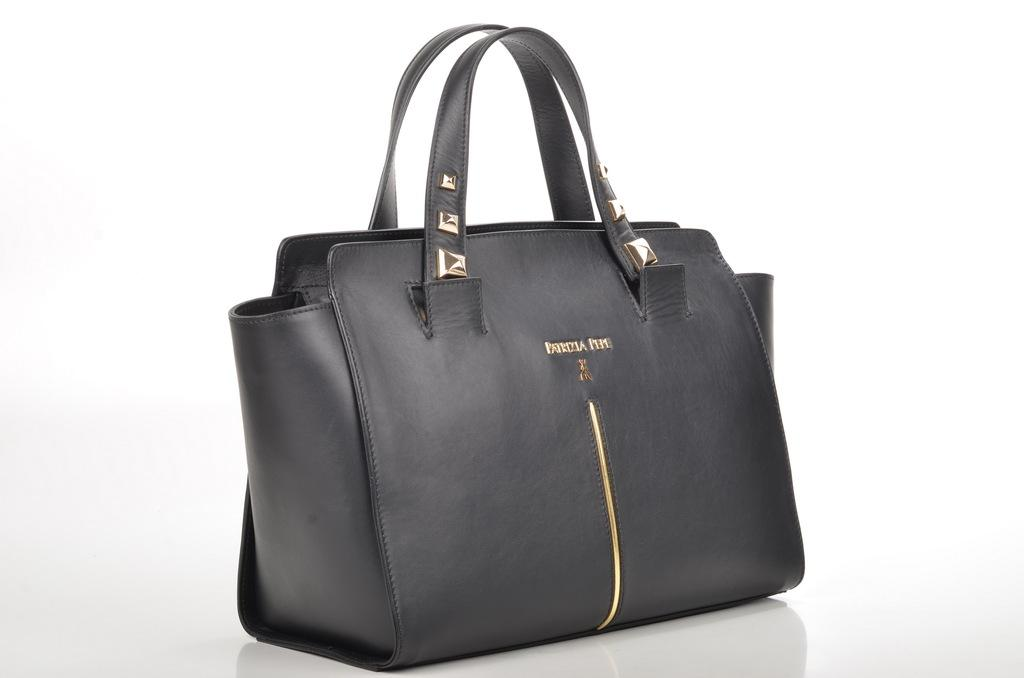What type of accessory is featured in the image? There is a black handbag in the image. How is the handbag emphasized in the image? The handbag is highlighted in the image. How many screws are visible on the handbag in the image? There are no screws visible on the handbag in the image. What type of education is being pursued by the handbag in the image? The handbag is an inanimate object and cannot pursue education. 